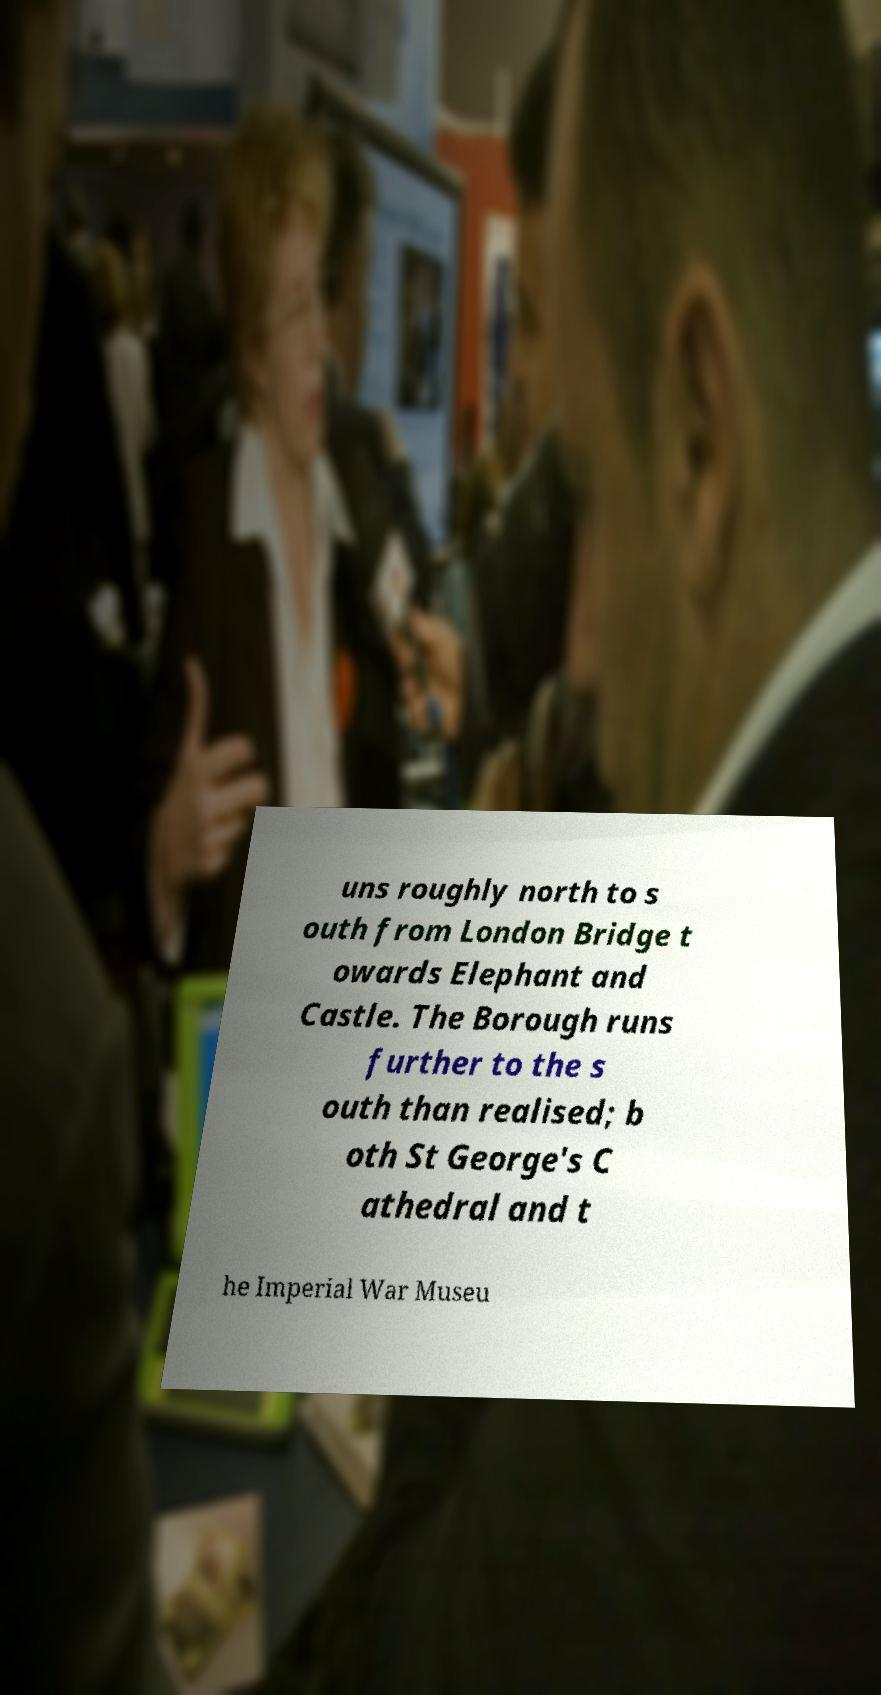What messages or text are displayed in this image? I need them in a readable, typed format. uns roughly north to s outh from London Bridge t owards Elephant and Castle. The Borough runs further to the s outh than realised; b oth St George's C athedral and t he Imperial War Museu 